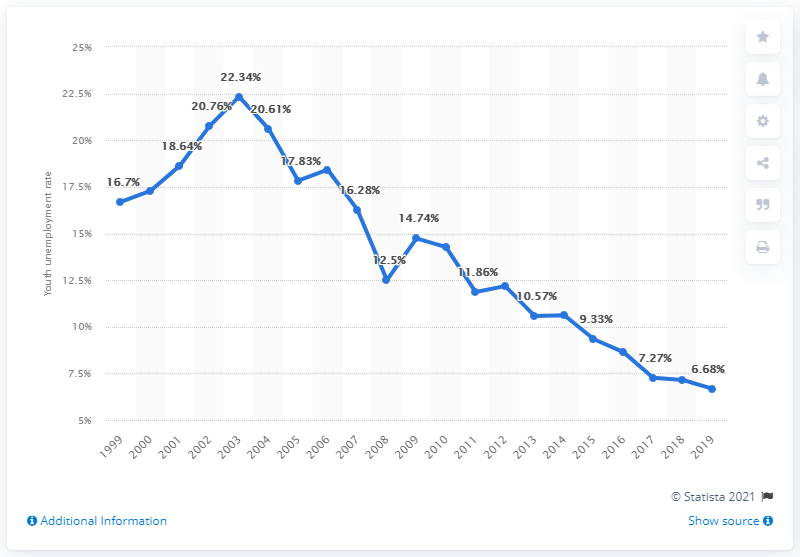Outline some significant characteristics in this image. In 2019, the youth unemployment rate in Israel was 6.68%. 